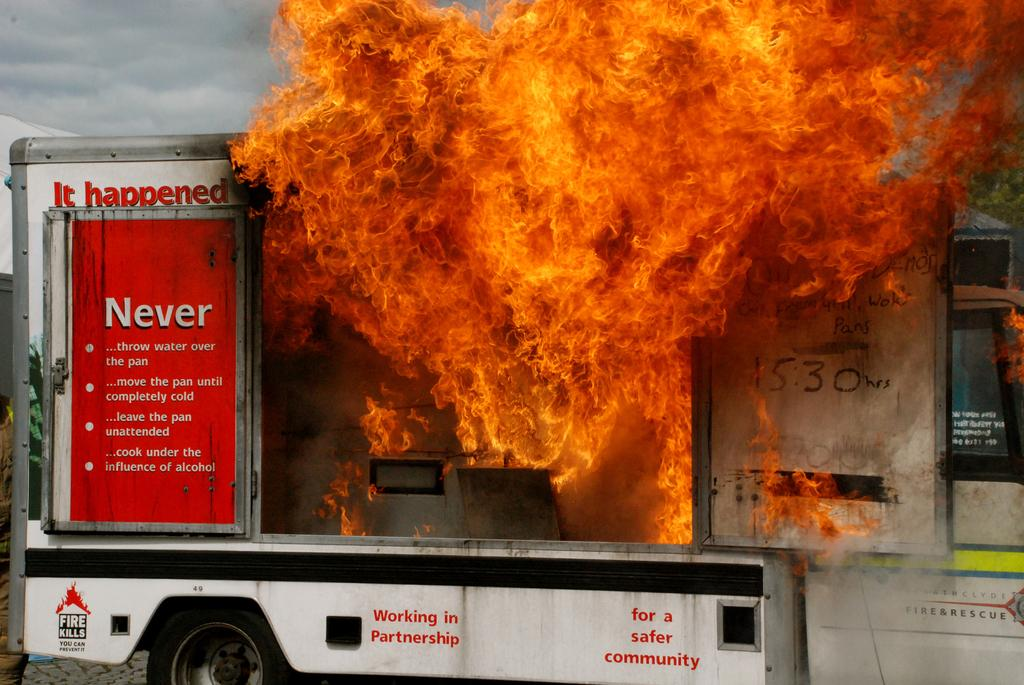What is the main subject of the image? The main subject of the image is a vehicle. What is happening to the vehicle in the image? The vehicle has caught fire. What letters are visible on the bike in the image? There is no bike present in the image, and therefore no letters can be observed on it. What is the interest rate of the vehicle in the image? The image does not provide information about interest rates, as it focuses on the vehicle catching fire. 